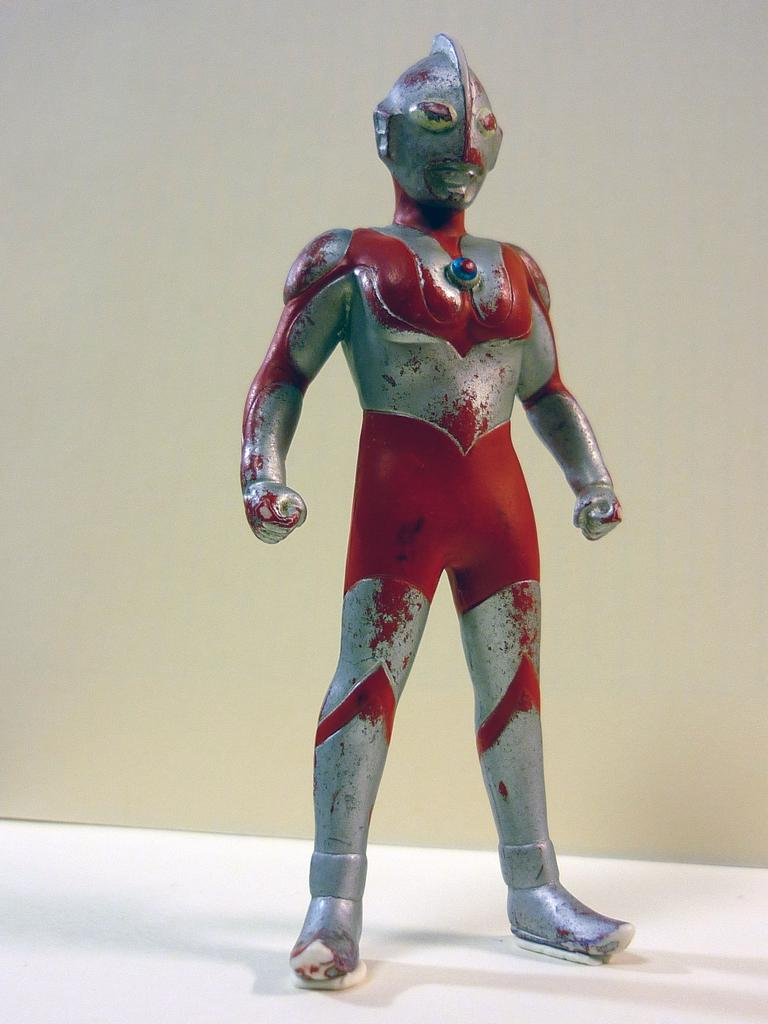What is the main subject in the image? There is a doll in the image. Can you describe the color of the doll? The doll is in red and grey color. What shape does the doll resemble? The doll is in the shape of a man. How many dimes are scattered around the doll in the image? There are no dimes present in the image; it only features a doll. What type of straw is the doll holding in the image? There is no straw present in the image; the doll is not holding anything. 